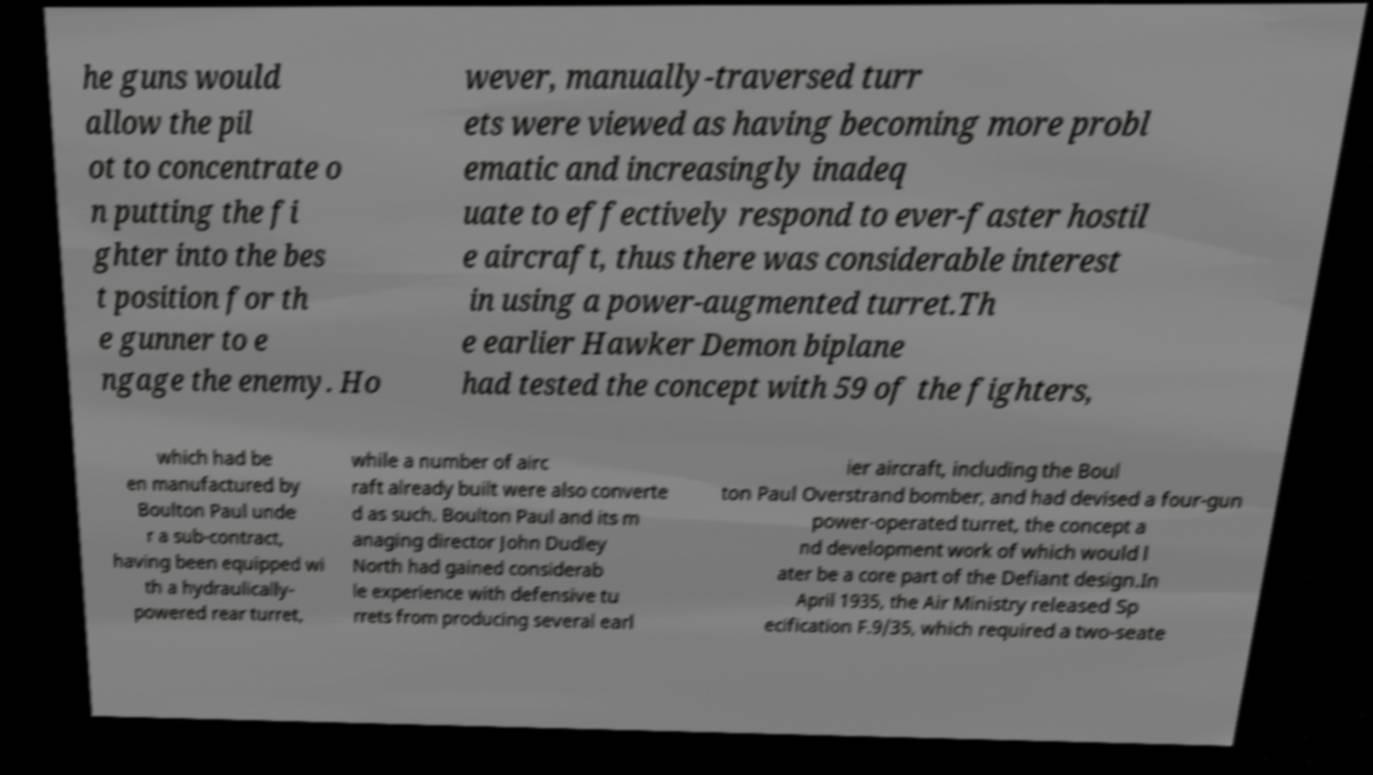Please identify and transcribe the text found in this image. he guns would allow the pil ot to concentrate o n putting the fi ghter into the bes t position for th e gunner to e ngage the enemy. Ho wever, manually-traversed turr ets were viewed as having becoming more probl ematic and increasingly inadeq uate to effectively respond to ever-faster hostil e aircraft, thus there was considerable interest in using a power-augmented turret.Th e earlier Hawker Demon biplane had tested the concept with 59 of the fighters, which had be en manufactured by Boulton Paul unde r a sub-contract, having been equipped wi th a hydraulically- powered rear turret, while a number of airc raft already built were also converte d as such. Boulton Paul and its m anaging director John Dudley North had gained considerab le experience with defensive tu rrets from producing several earl ier aircraft, including the Boul ton Paul Overstrand bomber, and had devised a four-gun power-operated turret, the concept a nd development work of which would l ater be a core part of the Defiant design.In April 1935, the Air Ministry released Sp ecification F.9/35, which required a two-seate 